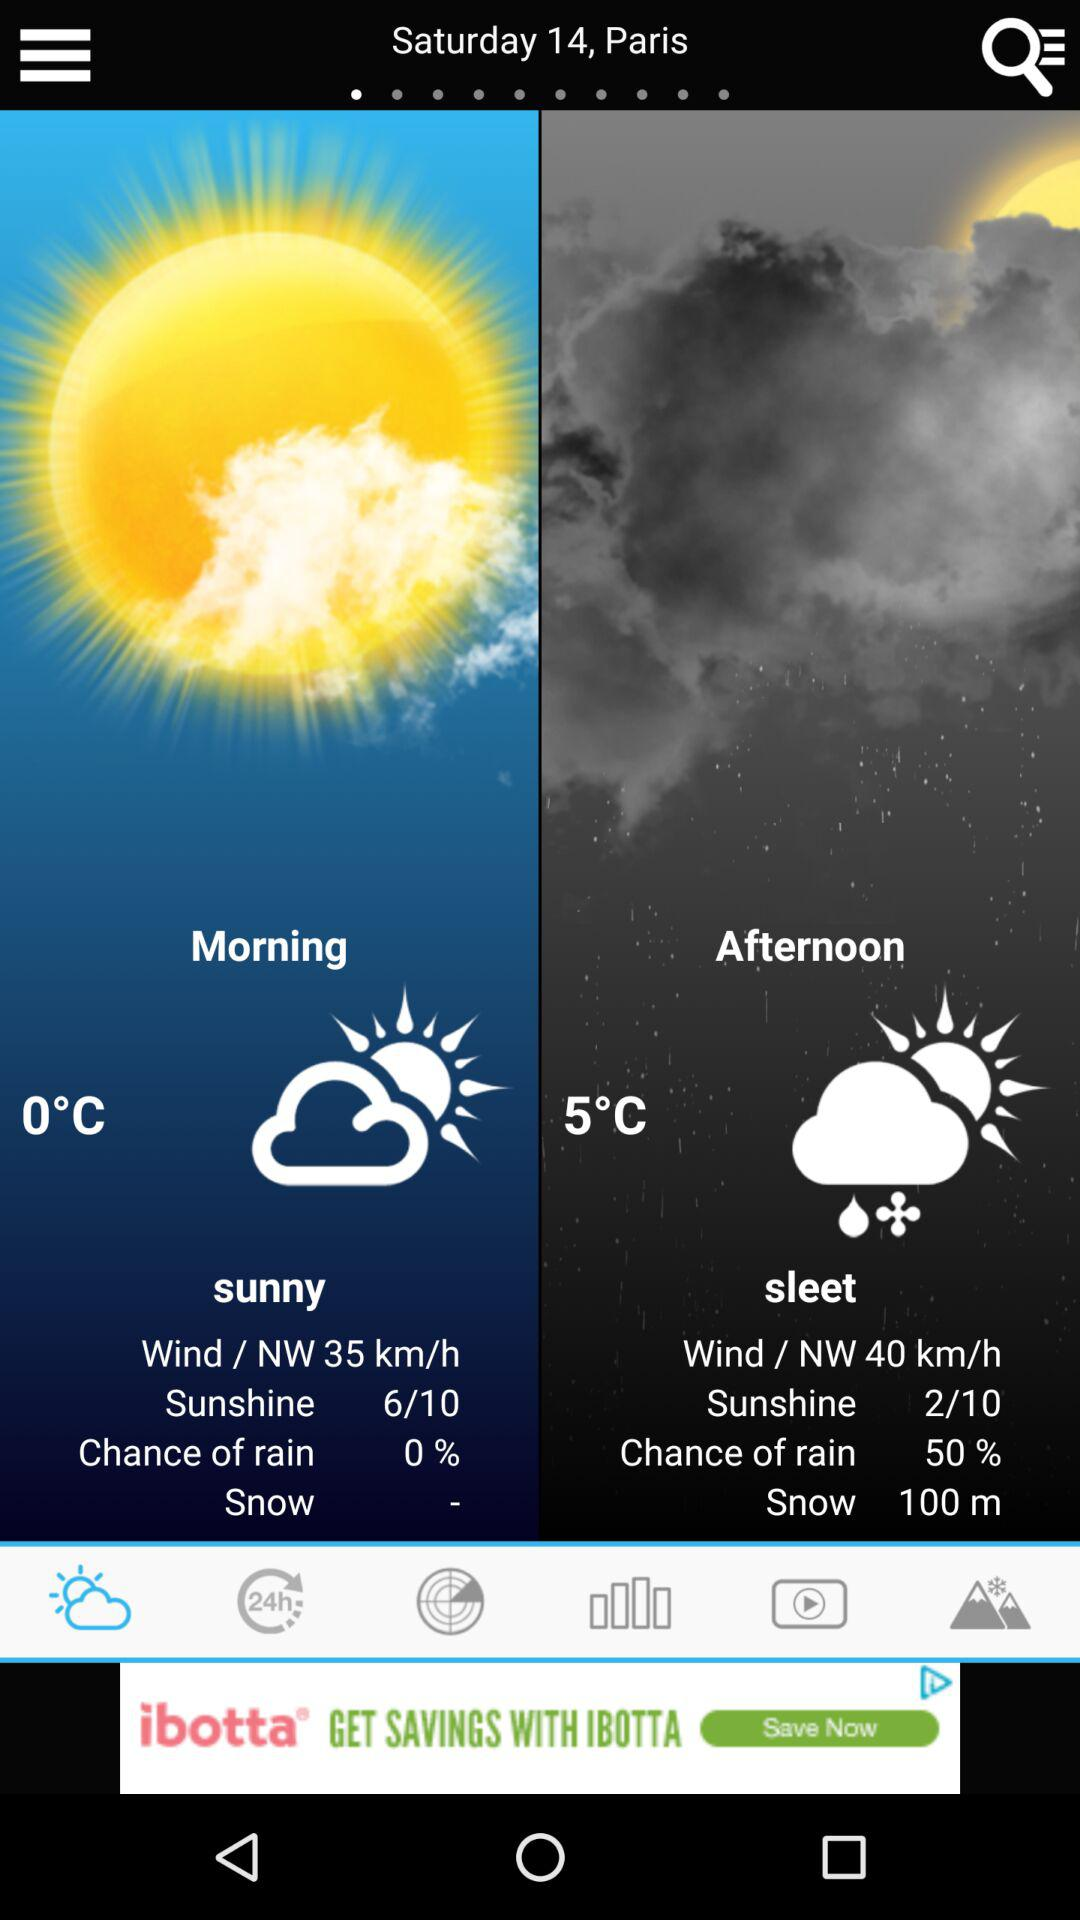What is the percentage chance that it will rain in the morning? The percentage chance that it will rain in the morning is 0. 